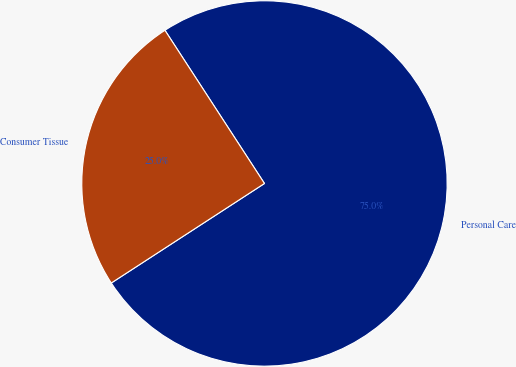Convert chart to OTSL. <chart><loc_0><loc_0><loc_500><loc_500><pie_chart><fcel>Personal Care<fcel>Consumer Tissue<nl><fcel>75.0%<fcel>25.0%<nl></chart> 